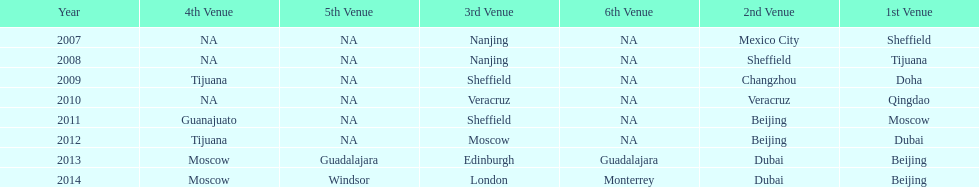In what year was the 3rd venue the same as 2011's 1st venue? 2012. 